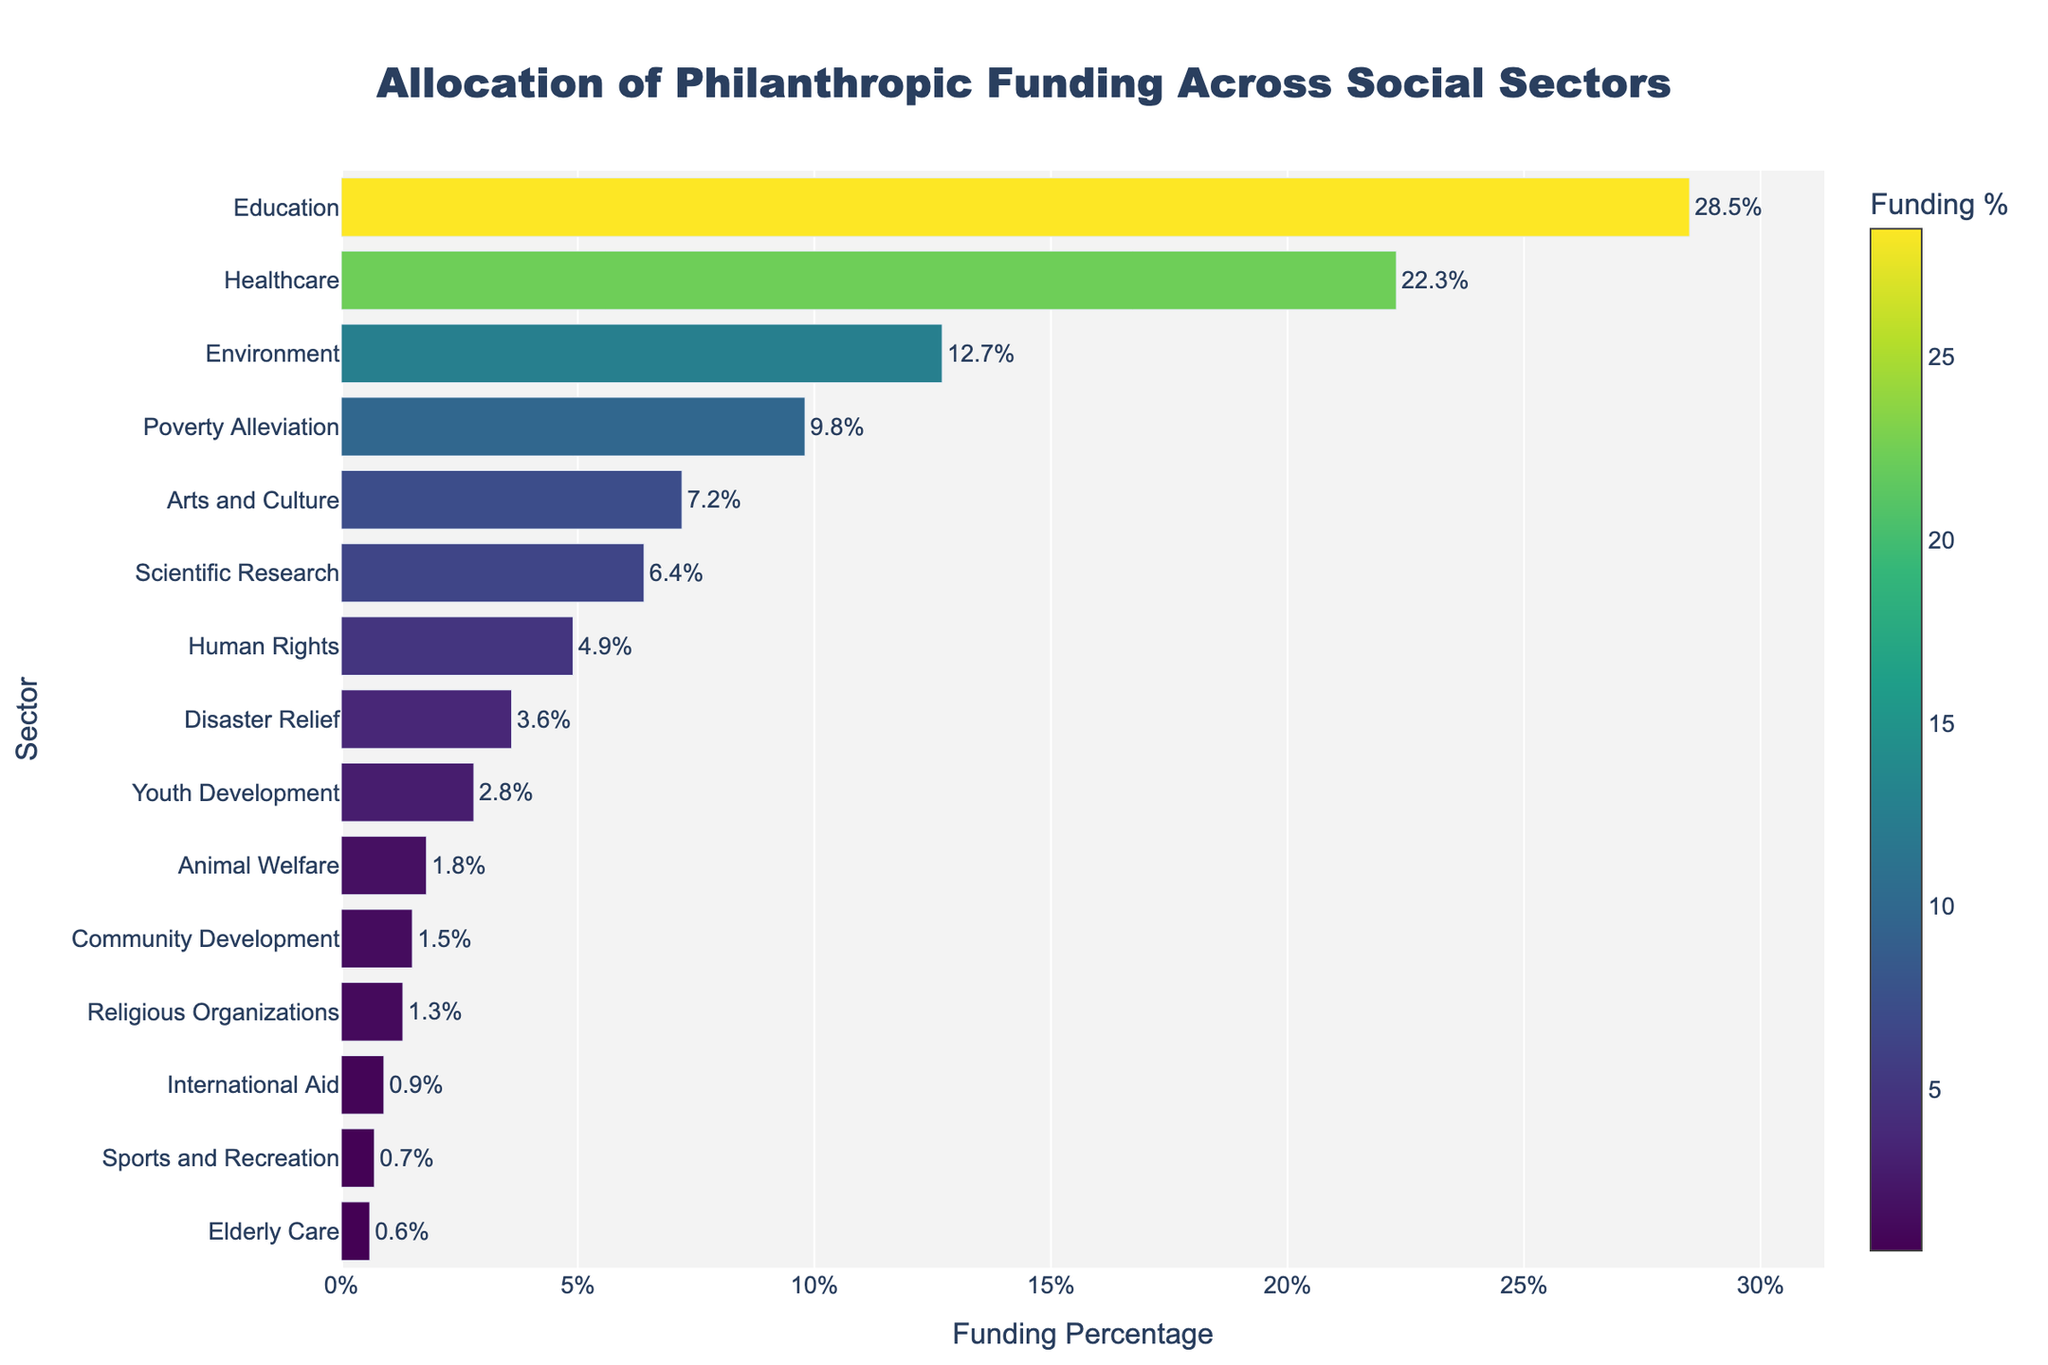Which sector receives the highest percentage of philanthropic funding? By observing the bar chart, identify the longest bar and read the label associated with it. The longest bar corresponds to the 'Education' sector with 28.5% funding.
Answer: Education What is the total percentage of funding allocated to Healthcare, Environment, and Poverty Alleviation combined? Sum the percentages for Healthcare (22.3%), Environment (12.7%), and Poverty Alleviation (9.8%). The total is 22.3 + 12.7 + 9.8 = 44.8%.
Answer: 44.8% Which sector has a percentage difference of 15.8% from the Healthcare sector? Find Healthcare's percentage (22.3%) and subtract 15.8%, 22.3 - 15.8 = 6.5%. Locate the sector with this resulting percentage, which is 'Scientific Research' at 6.4%, the closest value.
Answer: Scientific Research How much more funding does the Education sector receive compared to the Disaster Relief sector? Subtract the percentage of Disaster Relief (3.6%) from Education (28.5%). The difference is 28.5 - 3.6 = 24.9%.
Answer: 24.9% Which sector gets nearly double the funding of Youth Development? Double the percentage of Youth Development (2.8%) gives 5.6%. The closest sector to this value is 'Scientific Research' with 6.4%.
Answer: Scientific Research What percentage of funding is attributed to sectors that receive less than 5%? Identify sectors with <5%: Human Rights (4.9%), Disaster Relief (3.6%), Youth Development (2.8%), Animal Welfare (1.8%), Community Development (1.5%), Religious Organizations (1.3%), International Aid (0.9%), Sports and Recreation (0.7%), and Elderly Care (0.6%). Sum these: 4.9 + 3.6 + 2.8 + 1.8 + 1.5 + 1.3 + 0.9 + 0.7 + 0.6 = 18.1%.
Answer: 18.1% Which sector receives the least amount of philanthropic funding? Locate the shortest bar on the chart and read the sector label associated with it, which corresponds to 'Elderly Care' with 0.6%.
Answer: Elderly Care 